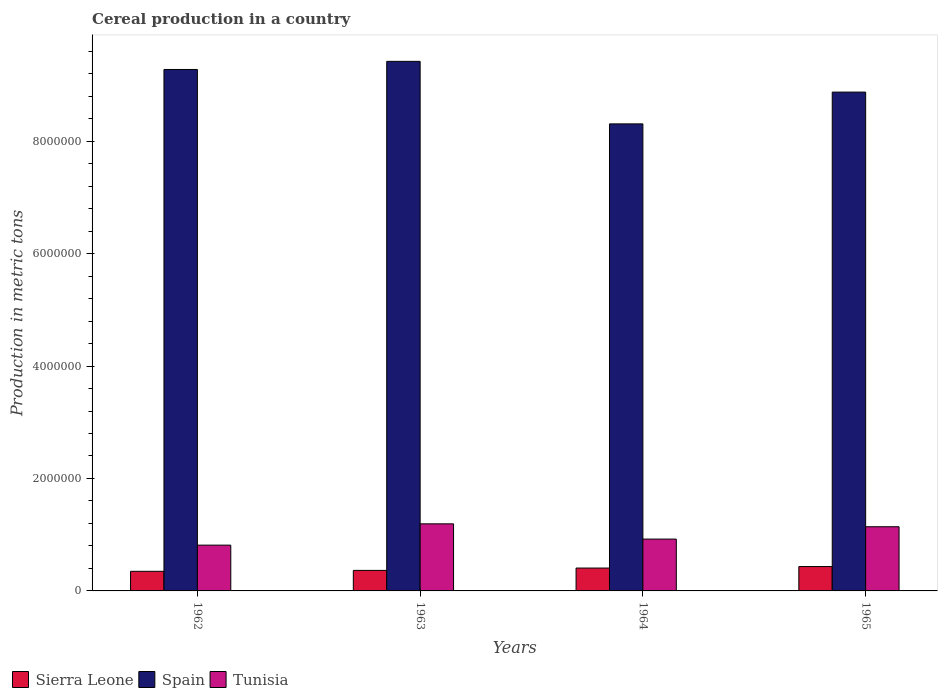Are the number of bars per tick equal to the number of legend labels?
Keep it short and to the point. Yes. Are the number of bars on each tick of the X-axis equal?
Your answer should be very brief. Yes. How many bars are there on the 4th tick from the right?
Ensure brevity in your answer.  3. What is the label of the 1st group of bars from the left?
Offer a very short reply. 1962. In how many cases, is the number of bars for a given year not equal to the number of legend labels?
Offer a very short reply. 0. What is the total cereal production in Tunisia in 1962?
Provide a short and direct response. 8.14e+05. Across all years, what is the maximum total cereal production in Spain?
Offer a very short reply. 9.42e+06. Across all years, what is the minimum total cereal production in Tunisia?
Give a very brief answer. 8.14e+05. In which year was the total cereal production in Tunisia maximum?
Your answer should be compact. 1963. What is the total total cereal production in Tunisia in the graph?
Your answer should be compact. 4.07e+06. What is the difference between the total cereal production in Sierra Leone in 1962 and that in 1964?
Ensure brevity in your answer.  -5.78e+04. What is the difference between the total cereal production in Spain in 1965 and the total cereal production in Sierra Leone in 1962?
Give a very brief answer. 8.52e+06. What is the average total cereal production in Sierra Leone per year?
Provide a short and direct response. 3.88e+05. In the year 1964, what is the difference between the total cereal production in Tunisia and total cereal production in Spain?
Give a very brief answer. -7.38e+06. In how many years, is the total cereal production in Tunisia greater than 4800000 metric tons?
Make the answer very short. 0. What is the ratio of the total cereal production in Tunisia in 1962 to that in 1963?
Give a very brief answer. 0.68. Is the total cereal production in Tunisia in 1962 less than that in 1964?
Provide a succinct answer. Yes. Is the difference between the total cereal production in Tunisia in 1963 and 1964 greater than the difference between the total cereal production in Spain in 1963 and 1964?
Your answer should be very brief. No. What is the difference between the highest and the second highest total cereal production in Sierra Leone?
Ensure brevity in your answer.  2.68e+04. What is the difference between the highest and the lowest total cereal production in Tunisia?
Ensure brevity in your answer.  3.79e+05. In how many years, is the total cereal production in Tunisia greater than the average total cereal production in Tunisia taken over all years?
Provide a succinct answer. 2. What does the 2nd bar from the left in 1964 represents?
Provide a short and direct response. Spain. What does the 1st bar from the right in 1963 represents?
Make the answer very short. Tunisia. Is it the case that in every year, the sum of the total cereal production in Spain and total cereal production in Tunisia is greater than the total cereal production in Sierra Leone?
Your answer should be very brief. Yes. Are all the bars in the graph horizontal?
Offer a terse response. No. What is the difference between two consecutive major ticks on the Y-axis?
Make the answer very short. 2.00e+06. Does the graph contain grids?
Make the answer very short. No. Where does the legend appear in the graph?
Ensure brevity in your answer.  Bottom left. How many legend labels are there?
Offer a very short reply. 3. How are the legend labels stacked?
Make the answer very short. Horizontal. What is the title of the graph?
Your answer should be very brief. Cereal production in a country. What is the label or title of the Y-axis?
Give a very brief answer. Production in metric tons. What is the Production in metric tons of Sierra Leone in 1962?
Make the answer very short. 3.49e+05. What is the Production in metric tons of Spain in 1962?
Your answer should be very brief. 9.27e+06. What is the Production in metric tons in Tunisia in 1962?
Offer a very short reply. 8.14e+05. What is the Production in metric tons in Sierra Leone in 1963?
Ensure brevity in your answer.  3.65e+05. What is the Production in metric tons of Spain in 1963?
Give a very brief answer. 9.42e+06. What is the Production in metric tons in Tunisia in 1963?
Provide a short and direct response. 1.19e+06. What is the Production in metric tons of Sierra Leone in 1964?
Give a very brief answer. 4.07e+05. What is the Production in metric tons in Spain in 1964?
Provide a succinct answer. 8.31e+06. What is the Production in metric tons in Tunisia in 1964?
Your response must be concise. 9.22e+05. What is the Production in metric tons in Sierra Leone in 1965?
Offer a very short reply. 4.33e+05. What is the Production in metric tons of Spain in 1965?
Keep it short and to the point. 8.87e+06. What is the Production in metric tons of Tunisia in 1965?
Your answer should be compact. 1.14e+06. Across all years, what is the maximum Production in metric tons of Sierra Leone?
Give a very brief answer. 4.33e+05. Across all years, what is the maximum Production in metric tons of Spain?
Make the answer very short. 9.42e+06. Across all years, what is the maximum Production in metric tons in Tunisia?
Keep it short and to the point. 1.19e+06. Across all years, what is the minimum Production in metric tons of Sierra Leone?
Your answer should be very brief. 3.49e+05. Across all years, what is the minimum Production in metric tons of Spain?
Provide a short and direct response. 8.31e+06. Across all years, what is the minimum Production in metric tons in Tunisia?
Offer a terse response. 8.14e+05. What is the total Production in metric tons of Sierra Leone in the graph?
Your answer should be compact. 1.55e+06. What is the total Production in metric tons in Spain in the graph?
Provide a succinct answer. 3.59e+07. What is the total Production in metric tons in Tunisia in the graph?
Ensure brevity in your answer.  4.07e+06. What is the difference between the Production in metric tons of Sierra Leone in 1962 and that in 1963?
Your response must be concise. -1.60e+04. What is the difference between the Production in metric tons in Spain in 1962 and that in 1963?
Provide a succinct answer. -1.45e+05. What is the difference between the Production in metric tons of Tunisia in 1962 and that in 1963?
Your answer should be compact. -3.79e+05. What is the difference between the Production in metric tons of Sierra Leone in 1962 and that in 1964?
Provide a short and direct response. -5.78e+04. What is the difference between the Production in metric tons in Spain in 1962 and that in 1964?
Make the answer very short. 9.68e+05. What is the difference between the Production in metric tons in Tunisia in 1962 and that in 1964?
Offer a terse response. -1.08e+05. What is the difference between the Production in metric tons of Sierra Leone in 1962 and that in 1965?
Your response must be concise. -8.46e+04. What is the difference between the Production in metric tons of Spain in 1962 and that in 1965?
Ensure brevity in your answer.  4.02e+05. What is the difference between the Production in metric tons of Tunisia in 1962 and that in 1965?
Provide a short and direct response. -3.27e+05. What is the difference between the Production in metric tons of Sierra Leone in 1963 and that in 1964?
Offer a terse response. -4.17e+04. What is the difference between the Production in metric tons of Spain in 1963 and that in 1964?
Offer a terse response. 1.11e+06. What is the difference between the Production in metric tons of Tunisia in 1963 and that in 1964?
Give a very brief answer. 2.71e+05. What is the difference between the Production in metric tons in Sierra Leone in 1963 and that in 1965?
Give a very brief answer. -6.86e+04. What is the difference between the Production in metric tons in Spain in 1963 and that in 1965?
Your answer should be very brief. 5.47e+05. What is the difference between the Production in metric tons of Tunisia in 1963 and that in 1965?
Provide a succinct answer. 5.18e+04. What is the difference between the Production in metric tons of Sierra Leone in 1964 and that in 1965?
Provide a short and direct response. -2.68e+04. What is the difference between the Production in metric tons of Spain in 1964 and that in 1965?
Give a very brief answer. -5.65e+05. What is the difference between the Production in metric tons of Tunisia in 1964 and that in 1965?
Provide a succinct answer. -2.20e+05. What is the difference between the Production in metric tons of Sierra Leone in 1962 and the Production in metric tons of Spain in 1963?
Provide a short and direct response. -9.07e+06. What is the difference between the Production in metric tons of Sierra Leone in 1962 and the Production in metric tons of Tunisia in 1963?
Your answer should be very brief. -8.44e+05. What is the difference between the Production in metric tons in Spain in 1962 and the Production in metric tons in Tunisia in 1963?
Offer a terse response. 8.08e+06. What is the difference between the Production in metric tons of Sierra Leone in 1962 and the Production in metric tons of Spain in 1964?
Keep it short and to the point. -7.96e+06. What is the difference between the Production in metric tons of Sierra Leone in 1962 and the Production in metric tons of Tunisia in 1964?
Make the answer very short. -5.73e+05. What is the difference between the Production in metric tons in Spain in 1962 and the Production in metric tons in Tunisia in 1964?
Your response must be concise. 8.35e+06. What is the difference between the Production in metric tons in Sierra Leone in 1962 and the Production in metric tons in Spain in 1965?
Ensure brevity in your answer.  -8.52e+06. What is the difference between the Production in metric tons of Sierra Leone in 1962 and the Production in metric tons of Tunisia in 1965?
Ensure brevity in your answer.  -7.93e+05. What is the difference between the Production in metric tons in Spain in 1962 and the Production in metric tons in Tunisia in 1965?
Your answer should be compact. 8.13e+06. What is the difference between the Production in metric tons in Sierra Leone in 1963 and the Production in metric tons in Spain in 1964?
Make the answer very short. -7.94e+06. What is the difference between the Production in metric tons in Sierra Leone in 1963 and the Production in metric tons in Tunisia in 1964?
Ensure brevity in your answer.  -5.57e+05. What is the difference between the Production in metric tons in Spain in 1963 and the Production in metric tons in Tunisia in 1964?
Make the answer very short. 8.50e+06. What is the difference between the Production in metric tons in Sierra Leone in 1963 and the Production in metric tons in Spain in 1965?
Your response must be concise. -8.51e+06. What is the difference between the Production in metric tons in Sierra Leone in 1963 and the Production in metric tons in Tunisia in 1965?
Keep it short and to the point. -7.77e+05. What is the difference between the Production in metric tons of Spain in 1963 and the Production in metric tons of Tunisia in 1965?
Give a very brief answer. 8.28e+06. What is the difference between the Production in metric tons of Sierra Leone in 1964 and the Production in metric tons of Spain in 1965?
Your response must be concise. -8.47e+06. What is the difference between the Production in metric tons in Sierra Leone in 1964 and the Production in metric tons in Tunisia in 1965?
Provide a short and direct response. -7.35e+05. What is the difference between the Production in metric tons of Spain in 1964 and the Production in metric tons of Tunisia in 1965?
Your answer should be very brief. 7.17e+06. What is the average Production in metric tons in Sierra Leone per year?
Keep it short and to the point. 3.88e+05. What is the average Production in metric tons in Spain per year?
Offer a very short reply. 8.97e+06. What is the average Production in metric tons of Tunisia per year?
Offer a very short reply. 1.02e+06. In the year 1962, what is the difference between the Production in metric tons of Sierra Leone and Production in metric tons of Spain?
Your response must be concise. -8.93e+06. In the year 1962, what is the difference between the Production in metric tons in Sierra Leone and Production in metric tons in Tunisia?
Offer a terse response. -4.66e+05. In the year 1962, what is the difference between the Production in metric tons of Spain and Production in metric tons of Tunisia?
Provide a succinct answer. 8.46e+06. In the year 1963, what is the difference between the Production in metric tons of Sierra Leone and Production in metric tons of Spain?
Your response must be concise. -9.05e+06. In the year 1963, what is the difference between the Production in metric tons in Sierra Leone and Production in metric tons in Tunisia?
Ensure brevity in your answer.  -8.28e+05. In the year 1963, what is the difference between the Production in metric tons in Spain and Production in metric tons in Tunisia?
Keep it short and to the point. 8.23e+06. In the year 1964, what is the difference between the Production in metric tons of Sierra Leone and Production in metric tons of Spain?
Your response must be concise. -7.90e+06. In the year 1964, what is the difference between the Production in metric tons of Sierra Leone and Production in metric tons of Tunisia?
Keep it short and to the point. -5.15e+05. In the year 1964, what is the difference between the Production in metric tons in Spain and Production in metric tons in Tunisia?
Give a very brief answer. 7.38e+06. In the year 1965, what is the difference between the Production in metric tons in Sierra Leone and Production in metric tons in Spain?
Make the answer very short. -8.44e+06. In the year 1965, what is the difference between the Production in metric tons of Sierra Leone and Production in metric tons of Tunisia?
Provide a succinct answer. -7.08e+05. In the year 1965, what is the difference between the Production in metric tons of Spain and Production in metric tons of Tunisia?
Ensure brevity in your answer.  7.73e+06. What is the ratio of the Production in metric tons in Sierra Leone in 1962 to that in 1963?
Offer a terse response. 0.96. What is the ratio of the Production in metric tons in Spain in 1962 to that in 1963?
Give a very brief answer. 0.98. What is the ratio of the Production in metric tons in Tunisia in 1962 to that in 1963?
Offer a very short reply. 0.68. What is the ratio of the Production in metric tons in Sierra Leone in 1962 to that in 1964?
Ensure brevity in your answer.  0.86. What is the ratio of the Production in metric tons in Spain in 1962 to that in 1964?
Offer a very short reply. 1.12. What is the ratio of the Production in metric tons of Tunisia in 1962 to that in 1964?
Provide a succinct answer. 0.88. What is the ratio of the Production in metric tons of Sierra Leone in 1962 to that in 1965?
Ensure brevity in your answer.  0.8. What is the ratio of the Production in metric tons of Spain in 1962 to that in 1965?
Provide a succinct answer. 1.05. What is the ratio of the Production in metric tons of Tunisia in 1962 to that in 1965?
Offer a terse response. 0.71. What is the ratio of the Production in metric tons in Sierra Leone in 1963 to that in 1964?
Your answer should be very brief. 0.9. What is the ratio of the Production in metric tons in Spain in 1963 to that in 1964?
Ensure brevity in your answer.  1.13. What is the ratio of the Production in metric tons in Tunisia in 1963 to that in 1964?
Make the answer very short. 1.29. What is the ratio of the Production in metric tons of Sierra Leone in 1963 to that in 1965?
Provide a succinct answer. 0.84. What is the ratio of the Production in metric tons of Spain in 1963 to that in 1965?
Your answer should be very brief. 1.06. What is the ratio of the Production in metric tons of Tunisia in 1963 to that in 1965?
Provide a short and direct response. 1.05. What is the ratio of the Production in metric tons in Sierra Leone in 1964 to that in 1965?
Your response must be concise. 0.94. What is the ratio of the Production in metric tons in Spain in 1964 to that in 1965?
Your answer should be very brief. 0.94. What is the ratio of the Production in metric tons in Tunisia in 1964 to that in 1965?
Your answer should be very brief. 0.81. What is the difference between the highest and the second highest Production in metric tons of Sierra Leone?
Your response must be concise. 2.68e+04. What is the difference between the highest and the second highest Production in metric tons in Spain?
Ensure brevity in your answer.  1.45e+05. What is the difference between the highest and the second highest Production in metric tons of Tunisia?
Give a very brief answer. 5.18e+04. What is the difference between the highest and the lowest Production in metric tons in Sierra Leone?
Give a very brief answer. 8.46e+04. What is the difference between the highest and the lowest Production in metric tons in Spain?
Ensure brevity in your answer.  1.11e+06. What is the difference between the highest and the lowest Production in metric tons of Tunisia?
Ensure brevity in your answer.  3.79e+05. 